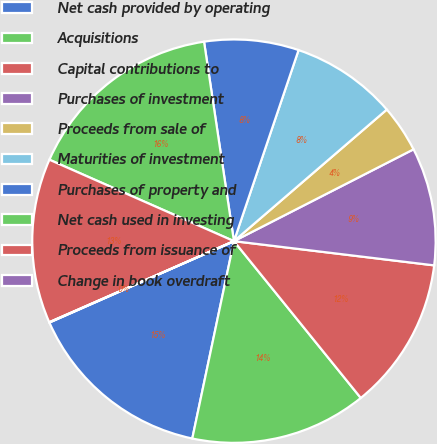Convert chart. <chart><loc_0><loc_0><loc_500><loc_500><pie_chart><fcel>Net cash provided by operating<fcel>Acquisitions<fcel>Capital contributions to<fcel>Purchases of investment<fcel>Proceeds from sale of<fcel>Maturities of investment<fcel>Purchases of property and<fcel>Net cash used in investing<fcel>Proceeds from issuance of<fcel>Change in book overdraft<nl><fcel>15.08%<fcel>14.14%<fcel>12.26%<fcel>9.44%<fcel>3.79%<fcel>8.5%<fcel>7.56%<fcel>16.02%<fcel>13.2%<fcel>0.03%<nl></chart> 